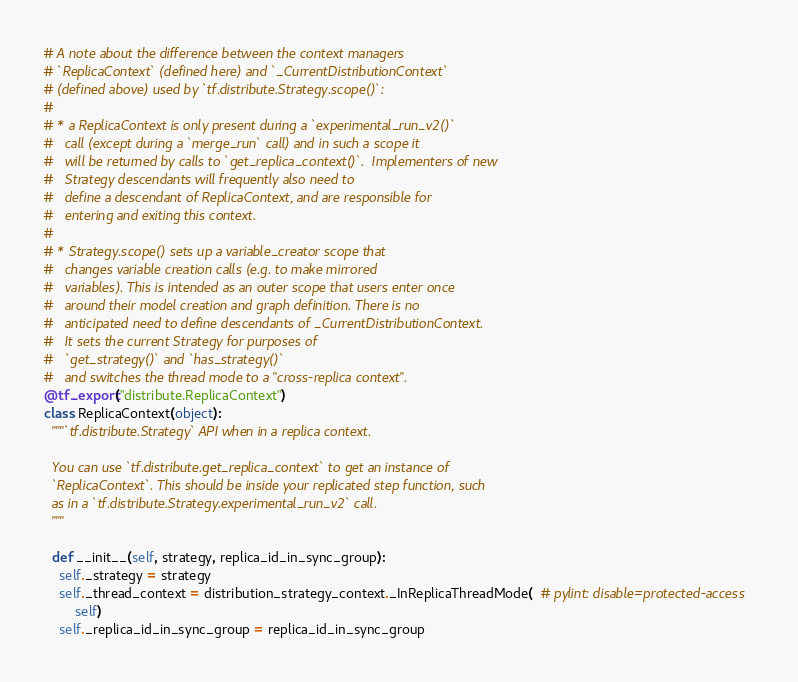<code> <loc_0><loc_0><loc_500><loc_500><_Python_>
# A note about the difference between the context managers
# `ReplicaContext` (defined here) and `_CurrentDistributionContext`
# (defined above) used by `tf.distribute.Strategy.scope()`:
#
# * a ReplicaContext is only present during a `experimental_run_v2()`
#   call (except during a `merge_run` call) and in such a scope it
#   will be returned by calls to `get_replica_context()`.  Implementers of new
#   Strategy descendants will frequently also need to
#   define a descendant of ReplicaContext, and are responsible for
#   entering and exiting this context.
#
# * Strategy.scope() sets up a variable_creator scope that
#   changes variable creation calls (e.g. to make mirrored
#   variables). This is intended as an outer scope that users enter once
#   around their model creation and graph definition. There is no
#   anticipated need to define descendants of _CurrentDistributionContext.
#   It sets the current Strategy for purposes of
#   `get_strategy()` and `has_strategy()`
#   and switches the thread mode to a "cross-replica context".
@tf_export("distribute.ReplicaContext")
class ReplicaContext(object):
  """`tf.distribute.Strategy` API when in a replica context.

  You can use `tf.distribute.get_replica_context` to get an instance of
  `ReplicaContext`. This should be inside your replicated step function, such
  as in a `tf.distribute.Strategy.experimental_run_v2` call.
  """

  def __init__(self, strategy, replica_id_in_sync_group):
    self._strategy = strategy
    self._thread_context = distribution_strategy_context._InReplicaThreadMode(  # pylint: disable=protected-access
        self)
    self._replica_id_in_sync_group = replica_id_in_sync_group</code> 